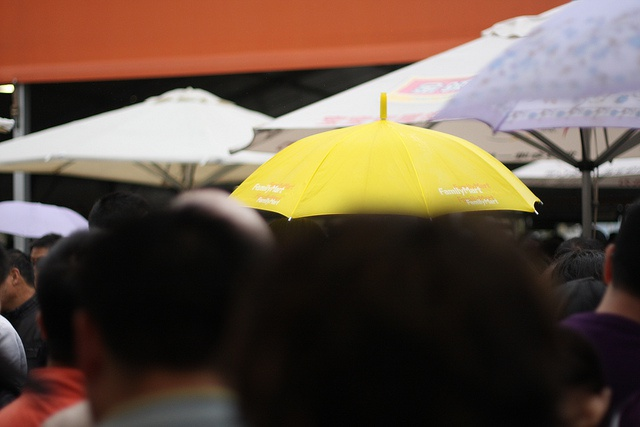Describe the objects in this image and their specific colors. I can see people in black and brown tones, people in brown, black, gray, and maroon tones, umbrella in brown, darkgray, lavender, and black tones, umbrella in brown, khaki, olive, and gold tones, and umbrella in brown, lightgray, tan, darkgray, and gray tones in this image. 